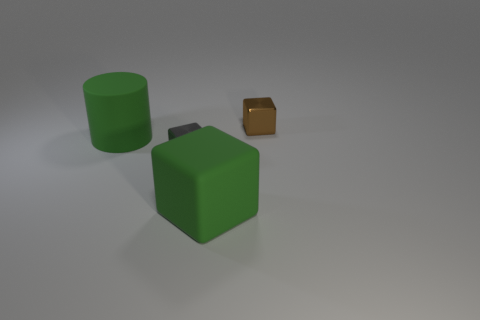Subtract all tiny blocks. How many blocks are left? 1 Subtract 2 blocks. How many blocks are left? 1 Subtract all brown balls. How many gray blocks are left? 1 Add 2 small cyan things. How many objects exist? 6 Subtract 0 yellow balls. How many objects are left? 4 Subtract all cylinders. How many objects are left? 3 Subtract all purple cylinders. Subtract all blue spheres. How many cylinders are left? 1 Subtract all green blocks. Subtract all brown metal blocks. How many objects are left? 2 Add 1 tiny brown metallic objects. How many tiny brown metallic objects are left? 2 Add 3 small blue metal things. How many small blue metal things exist? 3 